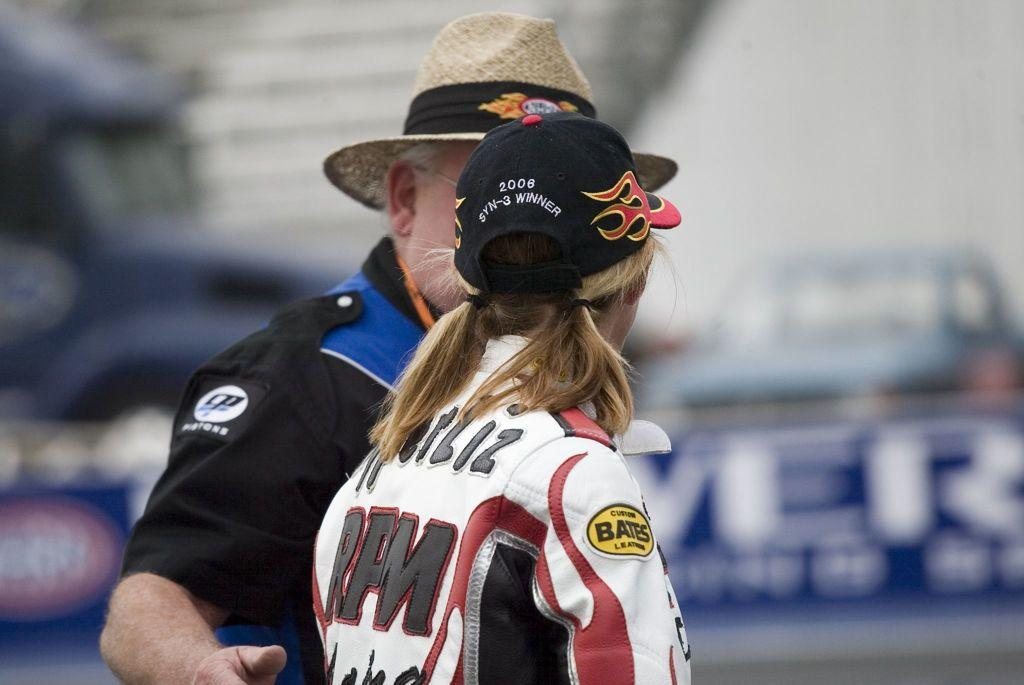Provide a one-sentence caption for the provided image. A man in a straw hat talks to a women wearing a black hat that says 2006 SYN-3 Winner on it. 